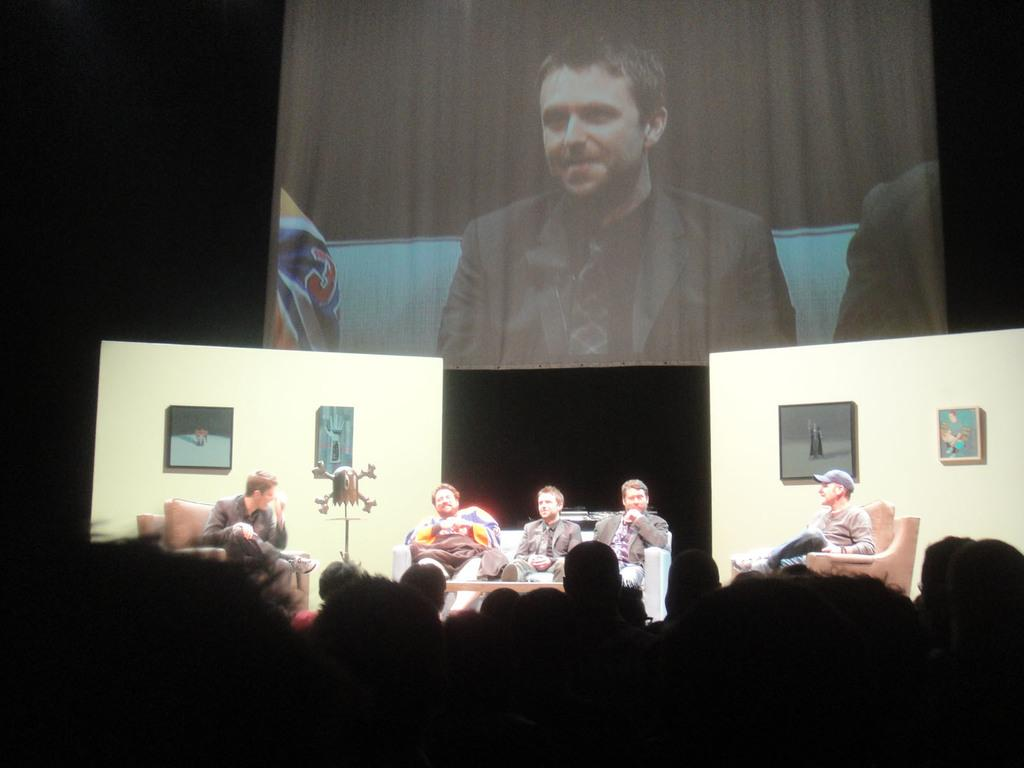What is the main object in the image? There is a projector screen in the image. What are the people in the image doing? The people are sitting on a sofa in the image. What can be seen on the walls in the image? There are photos on the walls in the image. What is the color or texture of the walls? The provided facts do not mention the color or texture of the walls. Can you see a squirrel climbing on the furniture in the image? There is no squirrel or furniture present in the image. 